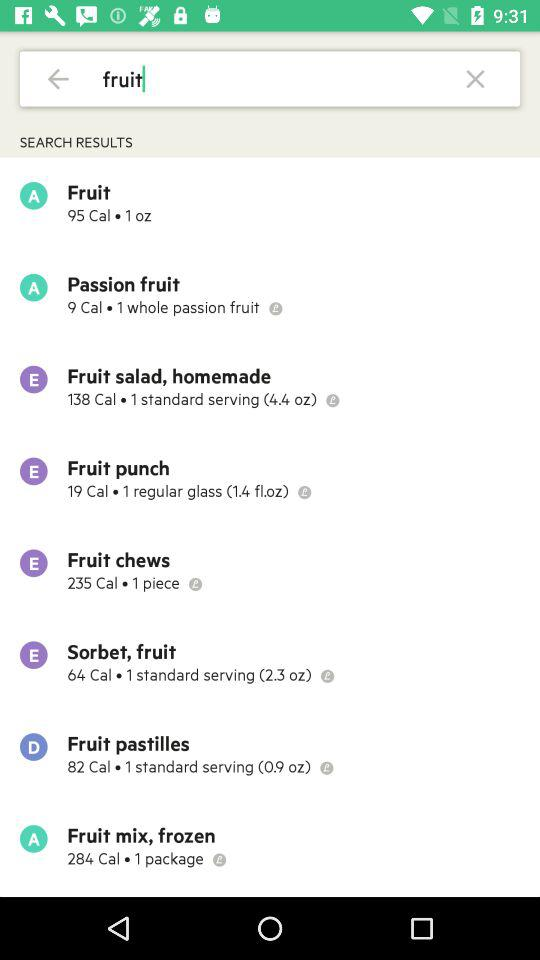How many calories are in "Fruit pastilles"? There are 82 calories in "Fruit pastilles". 